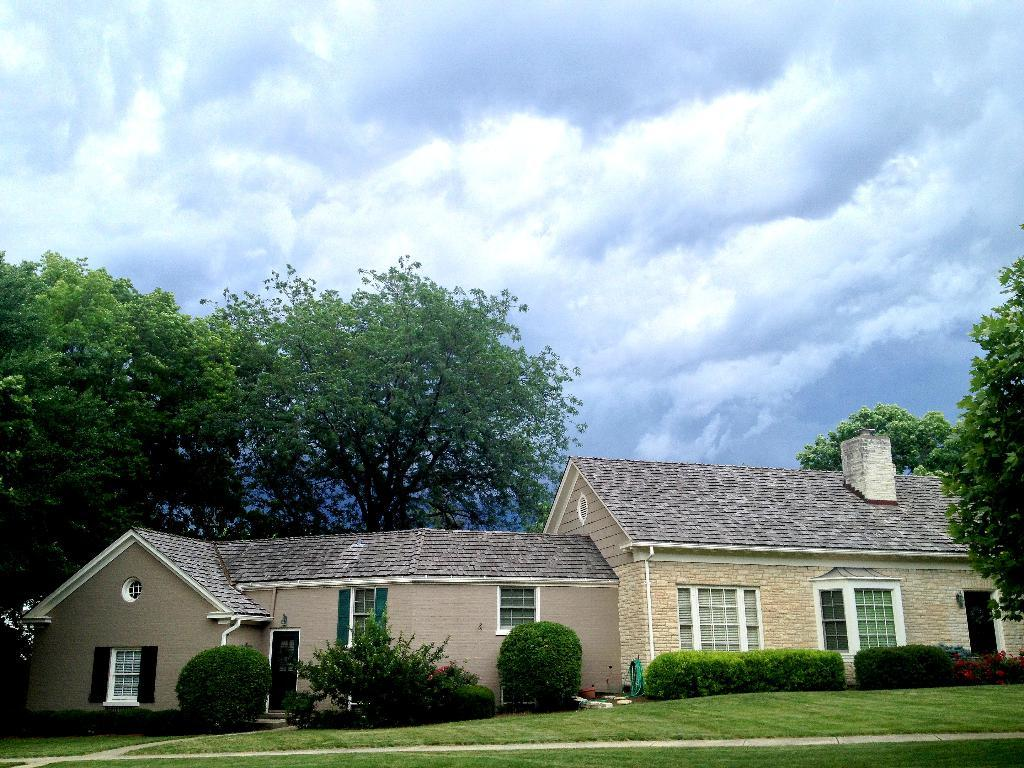What type of vegetation can be seen in the image? There are trees, plants, bushes, and grass in the image. What type of structures are visible in the image? There are houses in the image. What is the condition of the sky in the background of the image? The sky is cloudy in the background of the image. Who won the competition between the plants in the image? There is no competition between plants present in the image. Can you tell me how many uncles are visible in the image? There are no people, including uncles, present in the image. 